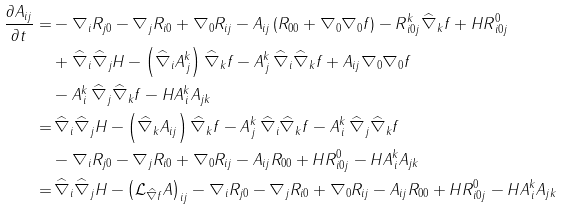Convert formula to latex. <formula><loc_0><loc_0><loc_500><loc_500>\frac { \partial A _ { i j } } { \partial t } = & - \nabla _ { i } R _ { j 0 } - \nabla _ { j } R _ { i 0 } + \nabla _ { 0 } R _ { i j } - A _ { i j } \left ( R _ { 0 0 } + \nabla _ { 0 } \nabla _ { 0 } f \right ) - R ^ { k } _ { \, i 0 j } \widehat { \nabla } _ { k } f + H R ^ { 0 } _ { \, i 0 j } \\ & + \widehat { \nabla } _ { i } \widehat { \nabla } _ { j } H - \left ( \widehat { \nabla } _ { i } A ^ { k } _ { \, j } \right ) \widehat { \nabla } _ { k } f - A ^ { k } _ { \, j } \, \widehat { \nabla } _ { i } \widehat { \nabla } _ { k } f + A _ { i j } \nabla _ { 0 } \nabla _ { 0 } f \\ & - A ^ { k } _ { \, i } \, \widehat { \nabla } _ { j } \widehat { \nabla } _ { k } f - H A ^ { k } _ { \, i } A _ { j k } \\ = & \, \widehat { \nabla } _ { i } \widehat { \nabla } _ { j } H - \left ( \widehat { \nabla } _ { k } A _ { i j } \right ) \widehat { \nabla } _ { k } f - A ^ { k } _ { \, j } \, \widehat { \nabla } _ { i } \widehat { \nabla } _ { k } f - A ^ { k } _ { \, i } \, \widehat { \nabla } _ { j } \widehat { \nabla } _ { k } f \\ & - \nabla _ { i } R _ { j 0 } - \nabla _ { j } R _ { i 0 } + \nabla _ { 0 } R _ { i j } - A _ { i j } R _ { 0 0 } + H R ^ { 0 } _ { \, i 0 j } - H A ^ { k } _ { \, i } A _ { j k } \\ = & \, \widehat { \nabla } _ { i } \widehat { \nabla } _ { j } H - \left ( { \mathcal { L } } _ { \widehat { \nabla } f } A \right ) _ { i j } - \nabla _ { i } R _ { j 0 } - \nabla _ { j } R _ { i 0 } + \nabla _ { 0 } R _ { i j } - A _ { i j } R _ { 0 0 } + H R ^ { 0 } _ { \, i 0 j } - H A ^ { k } _ { \, i } A _ { j k }</formula> 